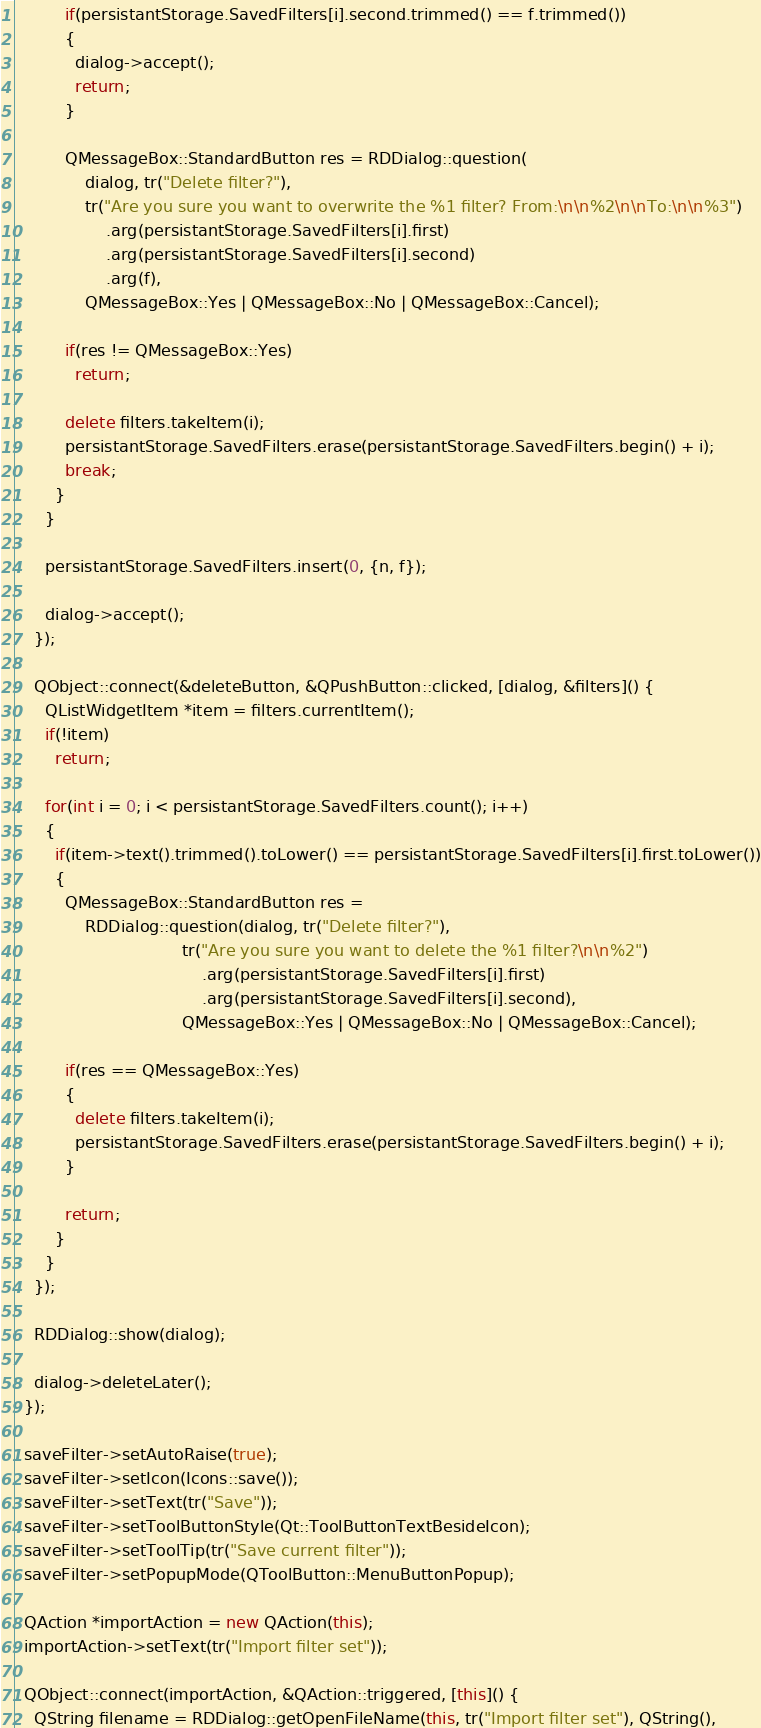Convert code to text. <code><loc_0><loc_0><loc_500><loc_500><_C++_>          if(persistantStorage.SavedFilters[i].second.trimmed() == f.trimmed())
          {
            dialog->accept();
            return;
          }

          QMessageBox::StandardButton res = RDDialog::question(
              dialog, tr("Delete filter?"),
              tr("Are you sure you want to overwrite the %1 filter? From:\n\n%2\n\nTo:\n\n%3")
                  .arg(persistantStorage.SavedFilters[i].first)
                  .arg(persistantStorage.SavedFilters[i].second)
                  .arg(f),
              QMessageBox::Yes | QMessageBox::No | QMessageBox::Cancel);

          if(res != QMessageBox::Yes)
            return;

          delete filters.takeItem(i);
          persistantStorage.SavedFilters.erase(persistantStorage.SavedFilters.begin() + i);
          break;
        }
      }

      persistantStorage.SavedFilters.insert(0, {n, f});

      dialog->accept();
    });

    QObject::connect(&deleteButton, &QPushButton::clicked, [dialog, &filters]() {
      QListWidgetItem *item = filters.currentItem();
      if(!item)
        return;

      for(int i = 0; i < persistantStorage.SavedFilters.count(); i++)
      {
        if(item->text().trimmed().toLower() == persistantStorage.SavedFilters[i].first.toLower())
        {
          QMessageBox::StandardButton res =
              RDDialog::question(dialog, tr("Delete filter?"),
                                 tr("Are you sure you want to delete the %1 filter?\n\n%2")
                                     .arg(persistantStorage.SavedFilters[i].first)
                                     .arg(persistantStorage.SavedFilters[i].second),
                                 QMessageBox::Yes | QMessageBox::No | QMessageBox::Cancel);

          if(res == QMessageBox::Yes)
          {
            delete filters.takeItem(i);
            persistantStorage.SavedFilters.erase(persistantStorage.SavedFilters.begin() + i);
          }

          return;
        }
      }
    });

    RDDialog::show(dialog);

    dialog->deleteLater();
  });

  saveFilter->setAutoRaise(true);
  saveFilter->setIcon(Icons::save());
  saveFilter->setText(tr("Save"));
  saveFilter->setToolButtonStyle(Qt::ToolButtonTextBesideIcon);
  saveFilter->setToolTip(tr("Save current filter"));
  saveFilter->setPopupMode(QToolButton::MenuButtonPopup);

  QAction *importAction = new QAction(this);
  importAction->setText(tr("Import filter set"));

  QObject::connect(importAction, &QAction::triggered, [this]() {
    QString filename = RDDialog::getOpenFileName(this, tr("Import filter set"), QString(),</code> 